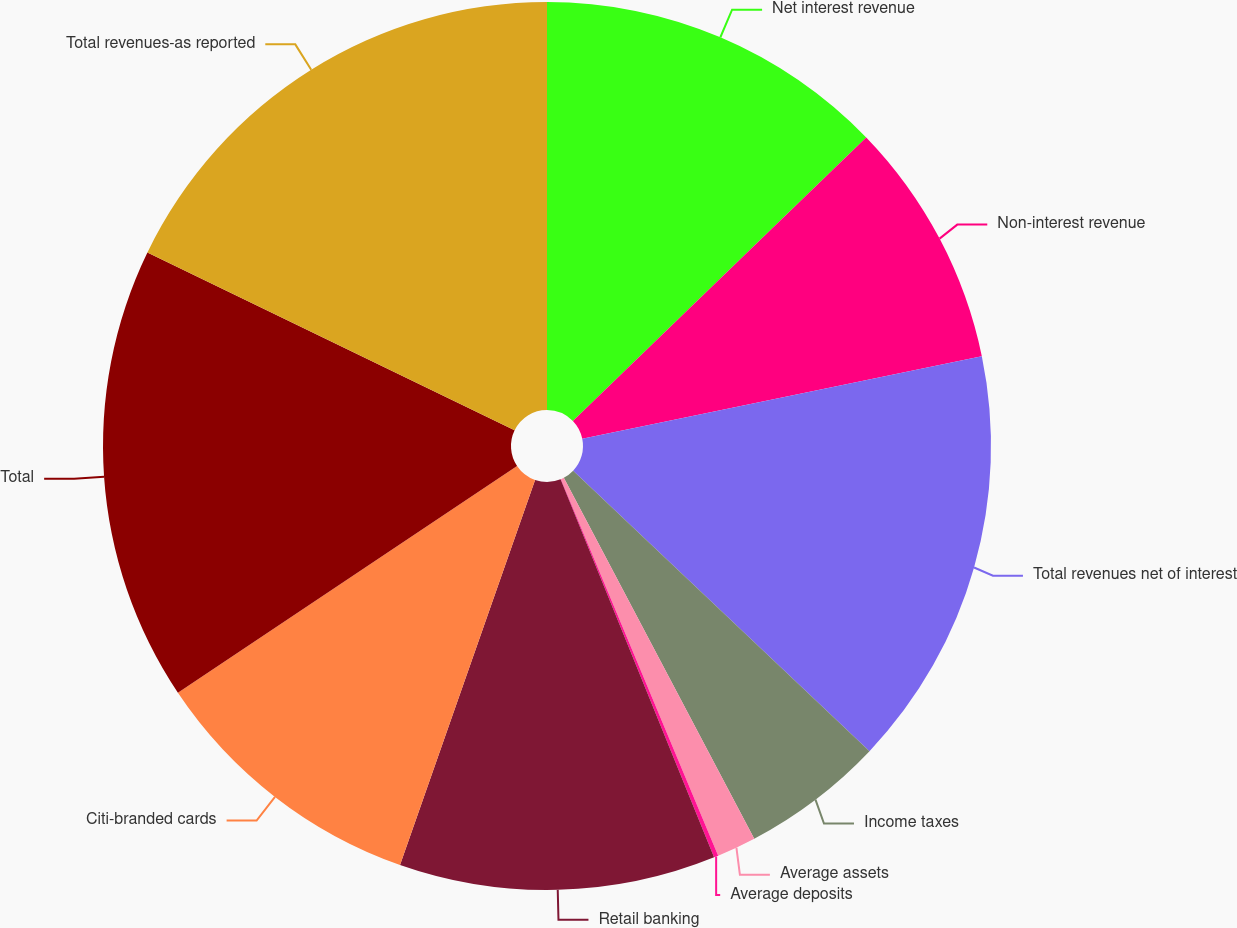Convert chart. <chart><loc_0><loc_0><loc_500><loc_500><pie_chart><fcel>Net interest revenue<fcel>Non-interest revenue<fcel>Total revenues net of interest<fcel>Income taxes<fcel>Average assets<fcel>Average deposits<fcel>Retail banking<fcel>Citi-branded cards<fcel>Total<fcel>Total revenues-as reported<nl><fcel>12.77%<fcel>8.99%<fcel>15.3%<fcel>5.21%<fcel>1.43%<fcel>0.16%<fcel>11.51%<fcel>10.25%<fcel>16.56%<fcel>17.82%<nl></chart> 